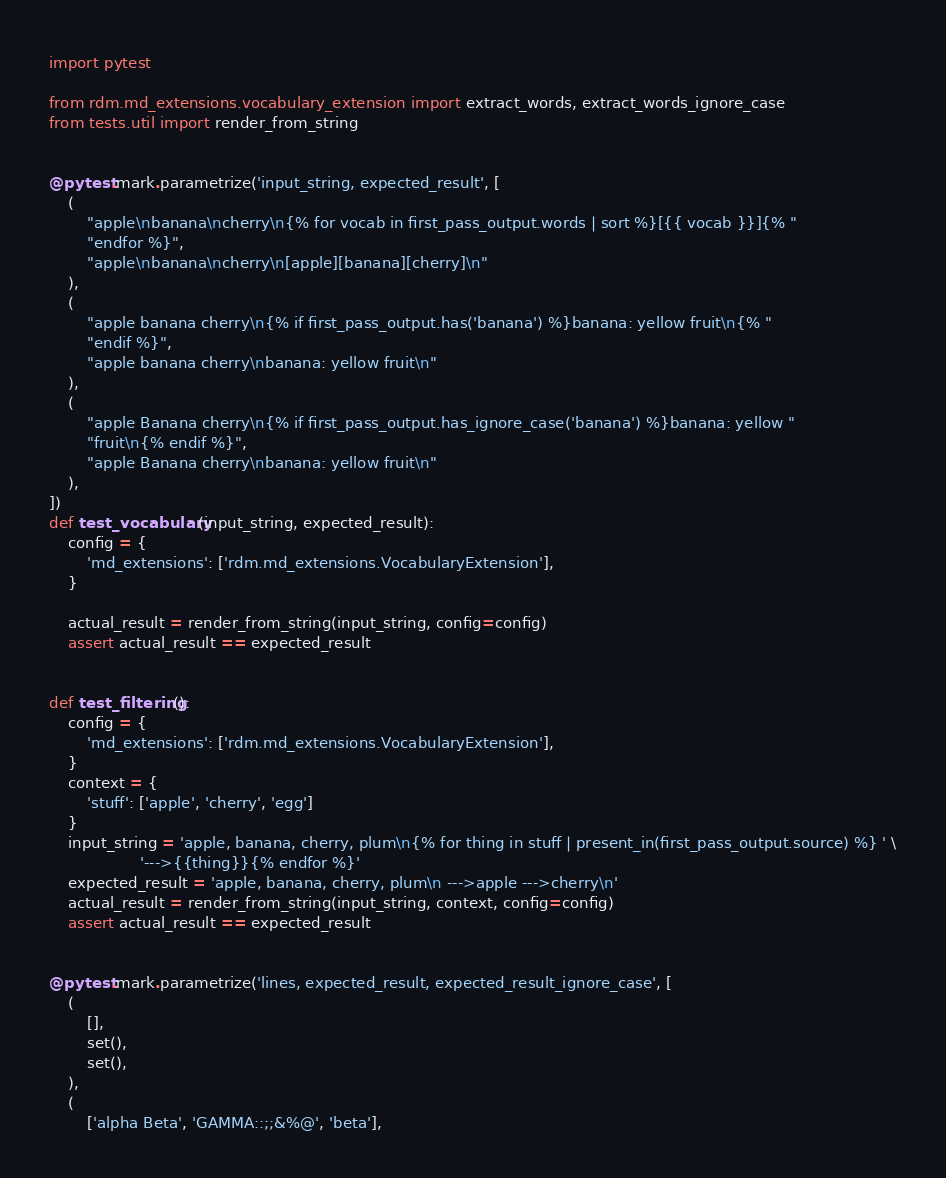<code> <loc_0><loc_0><loc_500><loc_500><_Python_>import pytest

from rdm.md_extensions.vocabulary_extension import extract_words, extract_words_ignore_case
from tests.util import render_from_string


@pytest.mark.parametrize('input_string, expected_result', [
    (
        "apple\nbanana\ncherry\n{% for vocab in first_pass_output.words | sort %}[{{ vocab }}]{% "
        "endfor %}",
        "apple\nbanana\ncherry\n[apple][banana][cherry]\n"
    ),
    (
        "apple banana cherry\n{% if first_pass_output.has('banana') %}banana: yellow fruit\n{% "
        "endif %}",
        "apple banana cherry\nbanana: yellow fruit\n"
    ),
    (
        "apple Banana cherry\n{% if first_pass_output.has_ignore_case('banana') %}banana: yellow "
        "fruit\n{% endif %}",
        "apple Banana cherry\nbanana: yellow fruit\n"
    ),
])
def test_vocabulary(input_string, expected_result):
    config = {
        'md_extensions': ['rdm.md_extensions.VocabularyExtension'],
    }

    actual_result = render_from_string(input_string, config=config)
    assert actual_result == expected_result


def test_filtering():
    config = {
        'md_extensions': ['rdm.md_extensions.VocabularyExtension'],
    }
    context = {
        'stuff': ['apple', 'cherry', 'egg']
    }
    input_string = 'apple, banana, cherry, plum\n{% for thing in stuff | present_in(first_pass_output.source) %} ' \
                   '--->{{thing}}{% endfor %}'
    expected_result = 'apple, banana, cherry, plum\n --->apple --->cherry\n'
    actual_result = render_from_string(input_string, context, config=config)
    assert actual_result == expected_result


@pytest.mark.parametrize('lines, expected_result, expected_result_ignore_case', [
    (
        [],
        set(),
        set(),
    ),
    (
        ['alpha Beta', 'GAMMA::;;&%@', 'beta'],</code> 